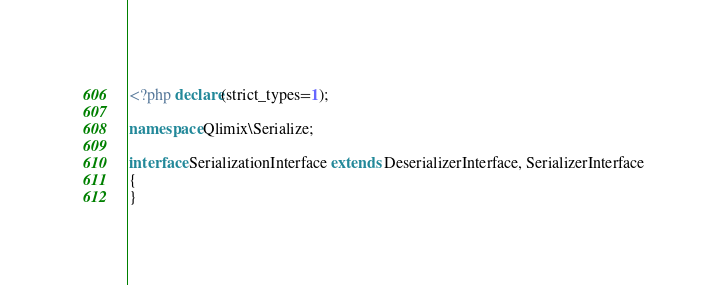<code> <loc_0><loc_0><loc_500><loc_500><_PHP_><?php declare(strict_types=1);

namespace Qlimix\Serialize;

interface SerializationInterface extends DeserializerInterface, SerializerInterface
{
}
</code> 